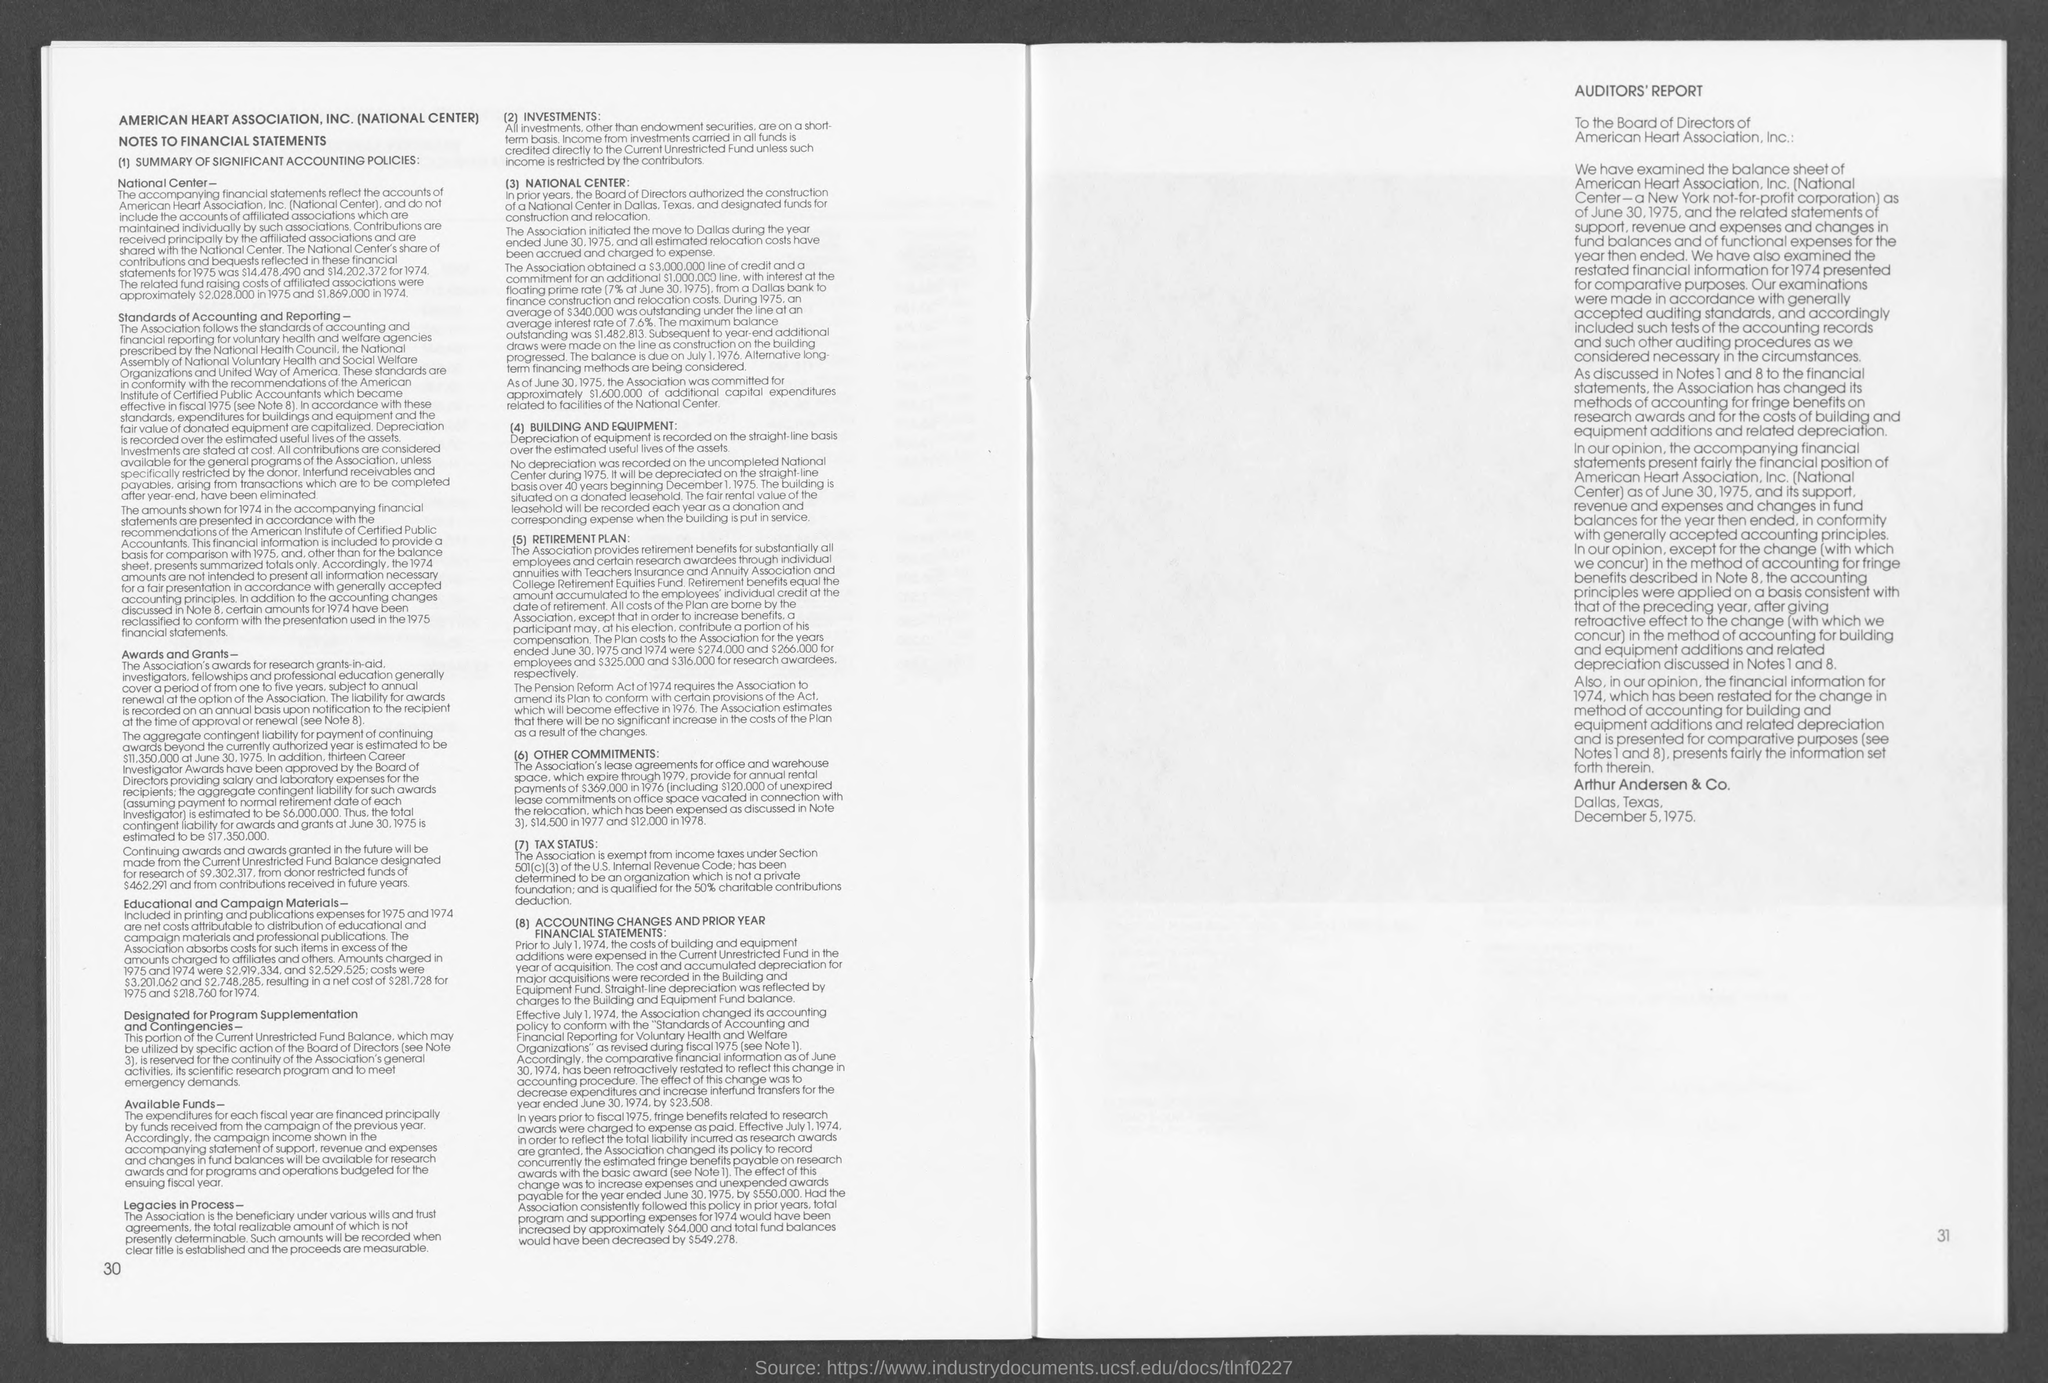Indicate a few pertinent items in this graphic. The investments are based on short-term gains. The Pension Reform Act was formed in 1974. 